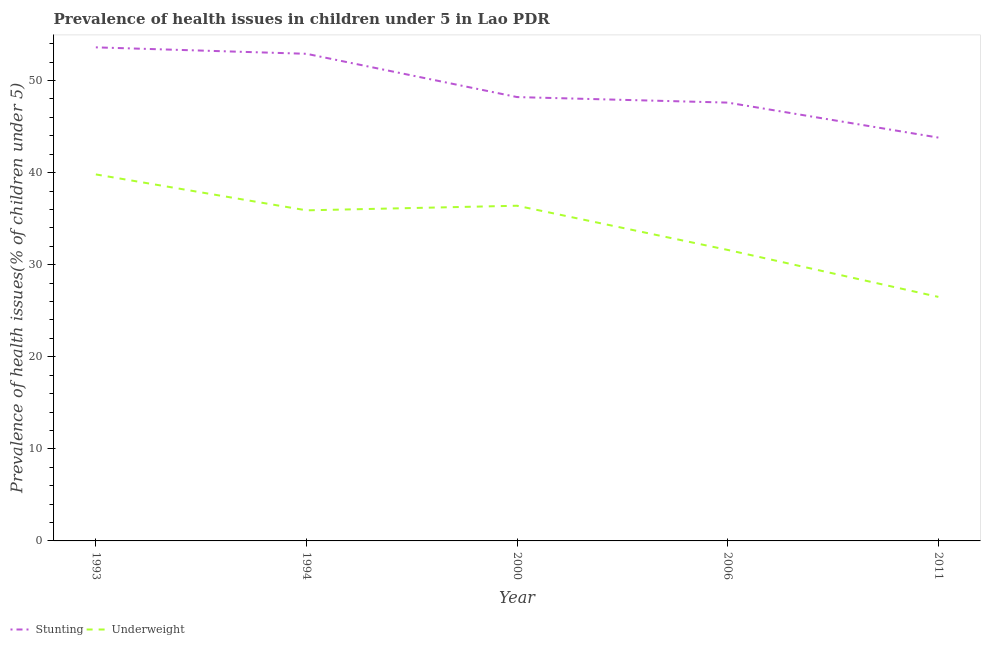How many different coloured lines are there?
Your response must be concise. 2. What is the percentage of underweight children in 1994?
Offer a very short reply. 35.9. Across all years, what is the maximum percentage of stunted children?
Offer a terse response. 53.6. Across all years, what is the minimum percentage of stunted children?
Keep it short and to the point. 43.8. In which year was the percentage of underweight children maximum?
Offer a terse response. 1993. What is the total percentage of stunted children in the graph?
Ensure brevity in your answer.  246.1. What is the difference between the percentage of stunted children in 1994 and that in 2000?
Keep it short and to the point. 4.7. What is the difference between the percentage of stunted children in 1994 and the percentage of underweight children in 1993?
Ensure brevity in your answer.  13.1. What is the average percentage of stunted children per year?
Offer a very short reply. 49.22. In the year 2011, what is the difference between the percentage of underweight children and percentage of stunted children?
Your answer should be very brief. -17.3. What is the ratio of the percentage of stunted children in 1993 to that in 2011?
Your response must be concise. 1.22. Is the difference between the percentage of stunted children in 2006 and 2011 greater than the difference between the percentage of underweight children in 2006 and 2011?
Your answer should be compact. No. What is the difference between the highest and the second highest percentage of stunted children?
Ensure brevity in your answer.  0.7. What is the difference between the highest and the lowest percentage of stunted children?
Your response must be concise. 9.8. Does the percentage of stunted children monotonically increase over the years?
Give a very brief answer. No. Is the percentage of underweight children strictly less than the percentage of stunted children over the years?
Your answer should be compact. Yes. How many lines are there?
Your answer should be very brief. 2. Does the graph contain any zero values?
Your answer should be very brief. No. Where does the legend appear in the graph?
Your response must be concise. Bottom left. How are the legend labels stacked?
Your answer should be very brief. Horizontal. What is the title of the graph?
Your response must be concise. Prevalence of health issues in children under 5 in Lao PDR. What is the label or title of the Y-axis?
Make the answer very short. Prevalence of health issues(% of children under 5). What is the Prevalence of health issues(% of children under 5) in Stunting in 1993?
Give a very brief answer. 53.6. What is the Prevalence of health issues(% of children under 5) in Underweight in 1993?
Provide a succinct answer. 39.8. What is the Prevalence of health issues(% of children under 5) of Stunting in 1994?
Ensure brevity in your answer.  52.9. What is the Prevalence of health issues(% of children under 5) in Underweight in 1994?
Keep it short and to the point. 35.9. What is the Prevalence of health issues(% of children under 5) in Stunting in 2000?
Your response must be concise. 48.2. What is the Prevalence of health issues(% of children under 5) of Underweight in 2000?
Your answer should be compact. 36.4. What is the Prevalence of health issues(% of children under 5) in Stunting in 2006?
Offer a terse response. 47.6. What is the Prevalence of health issues(% of children under 5) of Underweight in 2006?
Your answer should be compact. 31.6. What is the Prevalence of health issues(% of children under 5) in Stunting in 2011?
Provide a short and direct response. 43.8. What is the Prevalence of health issues(% of children under 5) of Underweight in 2011?
Provide a short and direct response. 26.5. Across all years, what is the maximum Prevalence of health issues(% of children under 5) of Stunting?
Your answer should be very brief. 53.6. Across all years, what is the maximum Prevalence of health issues(% of children under 5) of Underweight?
Provide a short and direct response. 39.8. Across all years, what is the minimum Prevalence of health issues(% of children under 5) of Stunting?
Your answer should be very brief. 43.8. Across all years, what is the minimum Prevalence of health issues(% of children under 5) in Underweight?
Keep it short and to the point. 26.5. What is the total Prevalence of health issues(% of children under 5) of Stunting in the graph?
Your response must be concise. 246.1. What is the total Prevalence of health issues(% of children under 5) of Underweight in the graph?
Offer a very short reply. 170.2. What is the difference between the Prevalence of health issues(% of children under 5) in Underweight in 1993 and that in 1994?
Offer a very short reply. 3.9. What is the difference between the Prevalence of health issues(% of children under 5) in Underweight in 1993 and that in 2000?
Provide a succinct answer. 3.4. What is the difference between the Prevalence of health issues(% of children under 5) of Stunting in 1993 and that in 2011?
Give a very brief answer. 9.8. What is the difference between the Prevalence of health issues(% of children under 5) in Stunting in 1994 and that in 2006?
Make the answer very short. 5.3. What is the difference between the Prevalence of health issues(% of children under 5) in Stunting in 2000 and that in 2006?
Your response must be concise. 0.6. What is the difference between the Prevalence of health issues(% of children under 5) in Underweight in 2000 and that in 2006?
Keep it short and to the point. 4.8. What is the difference between the Prevalence of health issues(% of children under 5) in Stunting in 2000 and that in 2011?
Provide a succinct answer. 4.4. What is the difference between the Prevalence of health issues(% of children under 5) in Stunting in 1993 and the Prevalence of health issues(% of children under 5) in Underweight in 2006?
Give a very brief answer. 22. What is the difference between the Prevalence of health issues(% of children under 5) of Stunting in 1993 and the Prevalence of health issues(% of children under 5) of Underweight in 2011?
Offer a terse response. 27.1. What is the difference between the Prevalence of health issues(% of children under 5) in Stunting in 1994 and the Prevalence of health issues(% of children under 5) in Underweight in 2006?
Give a very brief answer. 21.3. What is the difference between the Prevalence of health issues(% of children under 5) in Stunting in 1994 and the Prevalence of health issues(% of children under 5) in Underweight in 2011?
Provide a short and direct response. 26.4. What is the difference between the Prevalence of health issues(% of children under 5) in Stunting in 2000 and the Prevalence of health issues(% of children under 5) in Underweight in 2011?
Keep it short and to the point. 21.7. What is the difference between the Prevalence of health issues(% of children under 5) of Stunting in 2006 and the Prevalence of health issues(% of children under 5) of Underweight in 2011?
Keep it short and to the point. 21.1. What is the average Prevalence of health issues(% of children under 5) in Stunting per year?
Offer a very short reply. 49.22. What is the average Prevalence of health issues(% of children under 5) in Underweight per year?
Your answer should be compact. 34.04. In the year 1993, what is the difference between the Prevalence of health issues(% of children under 5) of Stunting and Prevalence of health issues(% of children under 5) of Underweight?
Make the answer very short. 13.8. In the year 2000, what is the difference between the Prevalence of health issues(% of children under 5) of Stunting and Prevalence of health issues(% of children under 5) of Underweight?
Give a very brief answer. 11.8. What is the ratio of the Prevalence of health issues(% of children under 5) in Stunting in 1993 to that in 1994?
Ensure brevity in your answer.  1.01. What is the ratio of the Prevalence of health issues(% of children under 5) of Underweight in 1993 to that in 1994?
Make the answer very short. 1.11. What is the ratio of the Prevalence of health issues(% of children under 5) in Stunting in 1993 to that in 2000?
Ensure brevity in your answer.  1.11. What is the ratio of the Prevalence of health issues(% of children under 5) in Underweight in 1993 to that in 2000?
Your response must be concise. 1.09. What is the ratio of the Prevalence of health issues(% of children under 5) in Stunting in 1993 to that in 2006?
Give a very brief answer. 1.13. What is the ratio of the Prevalence of health issues(% of children under 5) in Underweight in 1993 to that in 2006?
Offer a terse response. 1.26. What is the ratio of the Prevalence of health issues(% of children under 5) in Stunting in 1993 to that in 2011?
Provide a succinct answer. 1.22. What is the ratio of the Prevalence of health issues(% of children under 5) of Underweight in 1993 to that in 2011?
Give a very brief answer. 1.5. What is the ratio of the Prevalence of health issues(% of children under 5) of Stunting in 1994 to that in 2000?
Provide a short and direct response. 1.1. What is the ratio of the Prevalence of health issues(% of children under 5) in Underweight in 1994 to that in 2000?
Give a very brief answer. 0.99. What is the ratio of the Prevalence of health issues(% of children under 5) of Stunting in 1994 to that in 2006?
Keep it short and to the point. 1.11. What is the ratio of the Prevalence of health issues(% of children under 5) of Underweight in 1994 to that in 2006?
Ensure brevity in your answer.  1.14. What is the ratio of the Prevalence of health issues(% of children under 5) of Stunting in 1994 to that in 2011?
Give a very brief answer. 1.21. What is the ratio of the Prevalence of health issues(% of children under 5) of Underweight in 1994 to that in 2011?
Your answer should be very brief. 1.35. What is the ratio of the Prevalence of health issues(% of children under 5) in Stunting in 2000 to that in 2006?
Offer a very short reply. 1.01. What is the ratio of the Prevalence of health issues(% of children under 5) of Underweight in 2000 to that in 2006?
Provide a short and direct response. 1.15. What is the ratio of the Prevalence of health issues(% of children under 5) in Stunting in 2000 to that in 2011?
Keep it short and to the point. 1.1. What is the ratio of the Prevalence of health issues(% of children under 5) of Underweight in 2000 to that in 2011?
Give a very brief answer. 1.37. What is the ratio of the Prevalence of health issues(% of children under 5) in Stunting in 2006 to that in 2011?
Your answer should be compact. 1.09. What is the ratio of the Prevalence of health issues(% of children under 5) in Underweight in 2006 to that in 2011?
Your answer should be compact. 1.19. What is the difference between the highest and the second highest Prevalence of health issues(% of children under 5) of Stunting?
Your answer should be compact. 0.7. What is the difference between the highest and the second highest Prevalence of health issues(% of children under 5) of Underweight?
Ensure brevity in your answer.  3.4. What is the difference between the highest and the lowest Prevalence of health issues(% of children under 5) of Stunting?
Your answer should be compact. 9.8. 